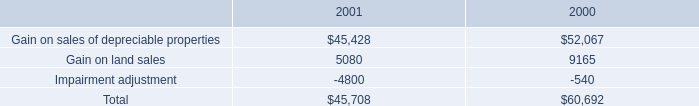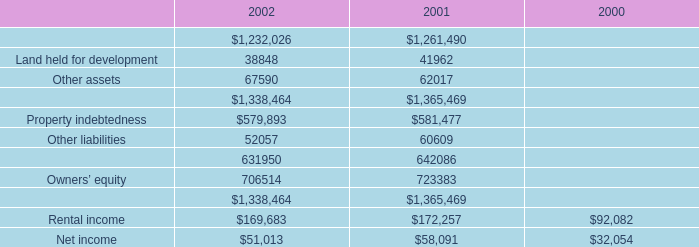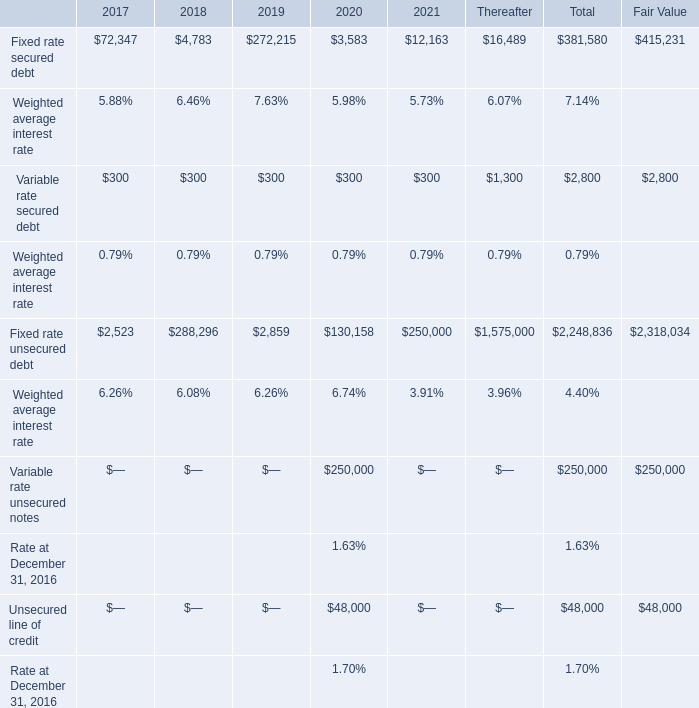what was the percentage change in the earnings from service operations increased from 2000 to 2001 
Computations: ((35.1 - 32.8) / 32.8)
Answer: 0.07012. 